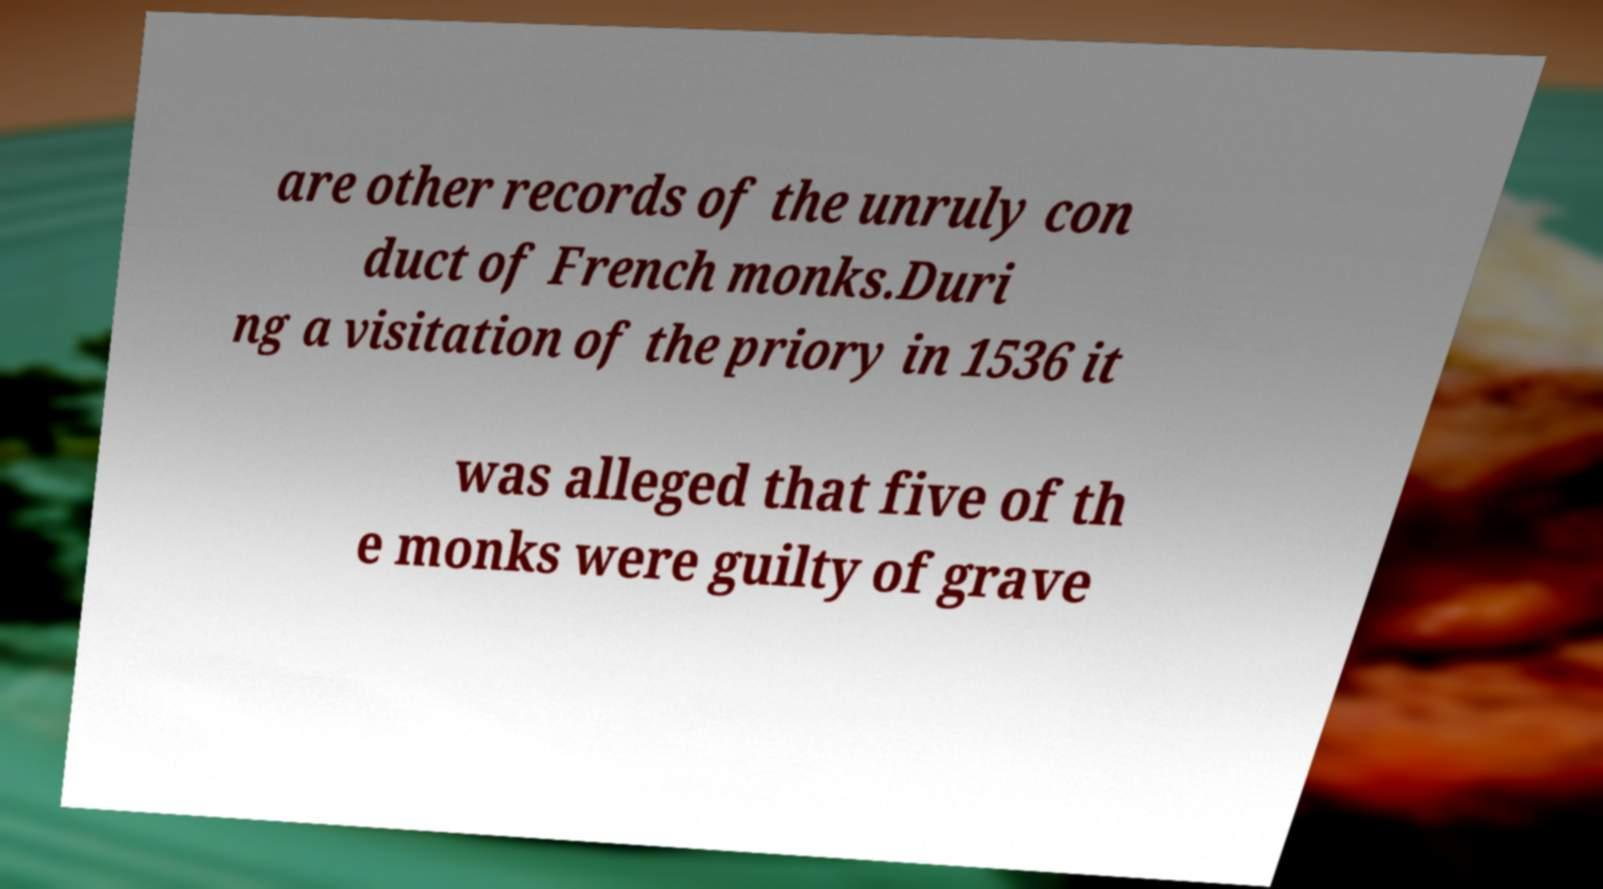Could you extract and type out the text from this image? are other records of the unruly con duct of French monks.Duri ng a visitation of the priory in 1536 it was alleged that five of th e monks were guilty of grave 